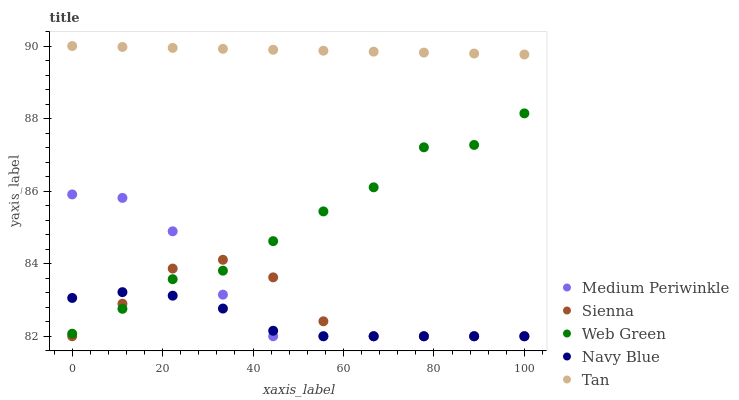Does Navy Blue have the minimum area under the curve?
Answer yes or no. Yes. Does Tan have the maximum area under the curve?
Answer yes or no. Yes. Does Tan have the minimum area under the curve?
Answer yes or no. No. Does Navy Blue have the maximum area under the curve?
Answer yes or no. No. Is Tan the smoothest?
Answer yes or no. Yes. Is Web Green the roughest?
Answer yes or no. Yes. Is Navy Blue the smoothest?
Answer yes or no. No. Is Navy Blue the roughest?
Answer yes or no. No. Does Sienna have the lowest value?
Answer yes or no. Yes. Does Tan have the lowest value?
Answer yes or no. No. Does Tan have the highest value?
Answer yes or no. Yes. Does Navy Blue have the highest value?
Answer yes or no. No. Is Web Green less than Tan?
Answer yes or no. Yes. Is Tan greater than Navy Blue?
Answer yes or no. Yes. Does Navy Blue intersect Web Green?
Answer yes or no. Yes. Is Navy Blue less than Web Green?
Answer yes or no. No. Is Navy Blue greater than Web Green?
Answer yes or no. No. Does Web Green intersect Tan?
Answer yes or no. No. 